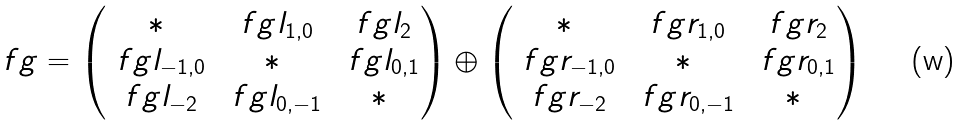<formula> <loc_0><loc_0><loc_500><loc_500>\ f g = \begin{pmatrix} * & \ f g l _ { 1 , 0 } & \ f g l _ { 2 } \\ \ f g l _ { - 1 , 0 } & * & \ f g l _ { 0 , 1 } \\ \ f g l _ { - 2 } & \ f g l _ { 0 , - 1 } & * \end{pmatrix} \oplus \begin{pmatrix} * & \ f g r _ { 1 , 0 } & \ f g r _ { 2 } \\ \ f g r _ { - 1 , 0 } & * & \ f g r _ { 0 , 1 } \\ \ f g r _ { - 2 } & \ f g r _ { 0 , - 1 } & * \end{pmatrix}</formula> 